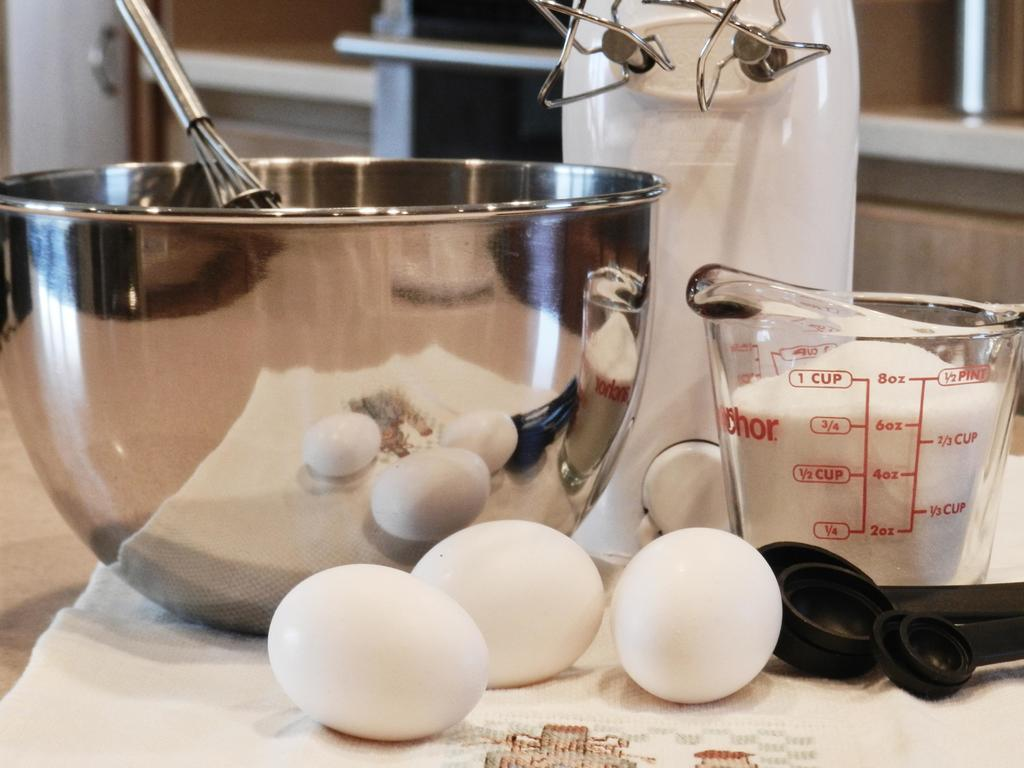<image>
Create a compact narrative representing the image presented. In this recipe, you seem to require 1 CUP of sugar. 